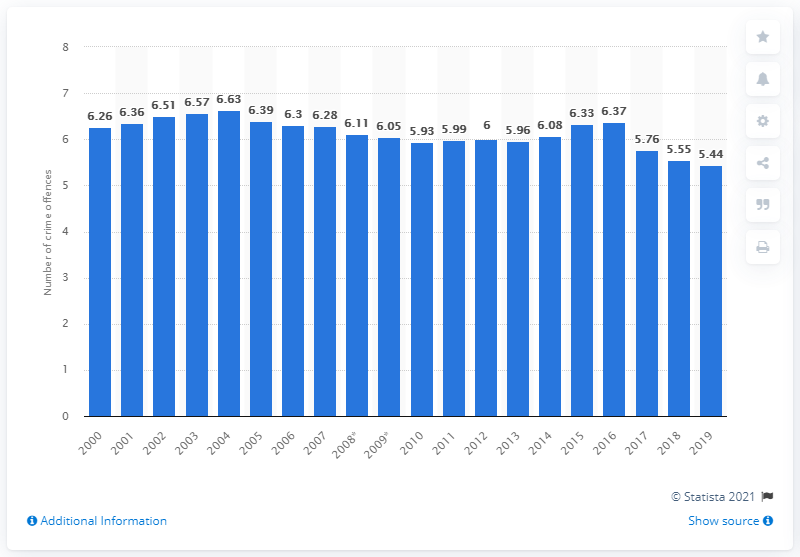Identify some key points in this picture. In 2004, the highest number of crimes in Germany was 6,634. The number of crimes recorded in Germany in 2019 was 5,440. 